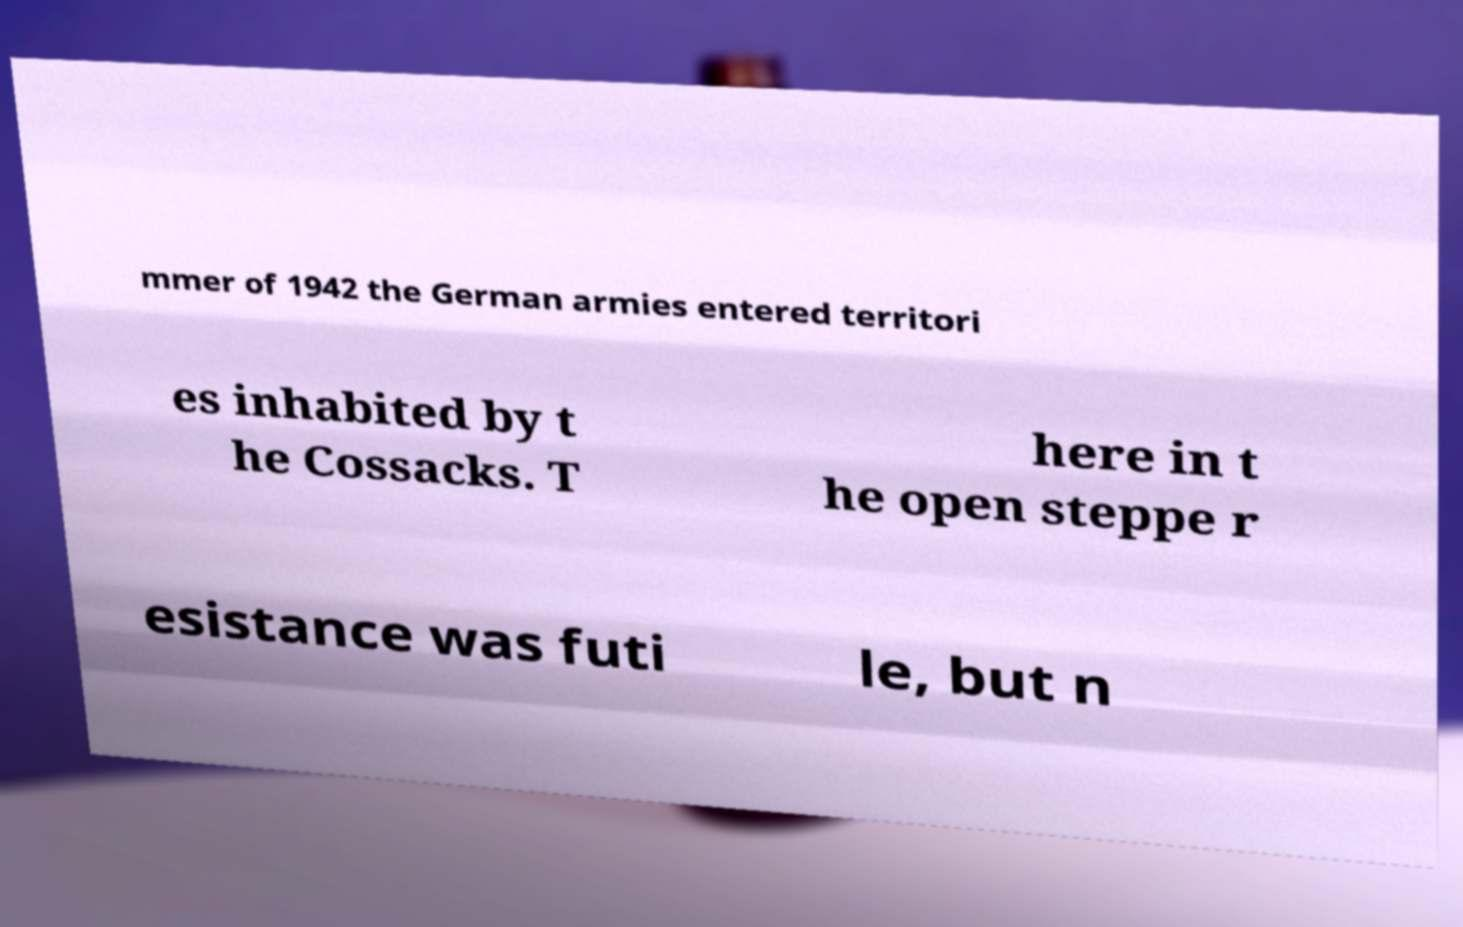Please identify and transcribe the text found in this image. mmer of 1942 the German armies entered territori es inhabited by t he Cossacks. T here in t he open steppe r esistance was futi le, but n 